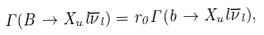Convert formula to latex. <formula><loc_0><loc_0><loc_500><loc_500>\Gamma ( B \to X _ { u } l \overline { \nu } _ { l } ) = r _ { 0 } \Gamma ( b \to X _ { u } l \overline { \nu } _ { l } ) ,</formula> 